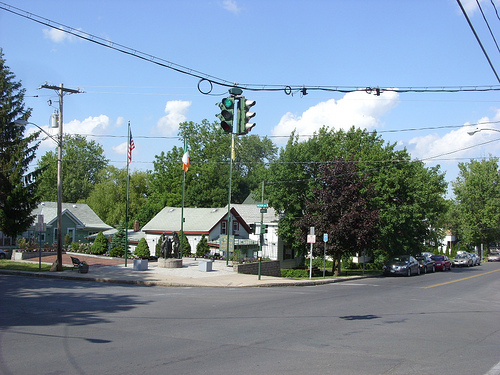How many black horse are there in the image ? 0 